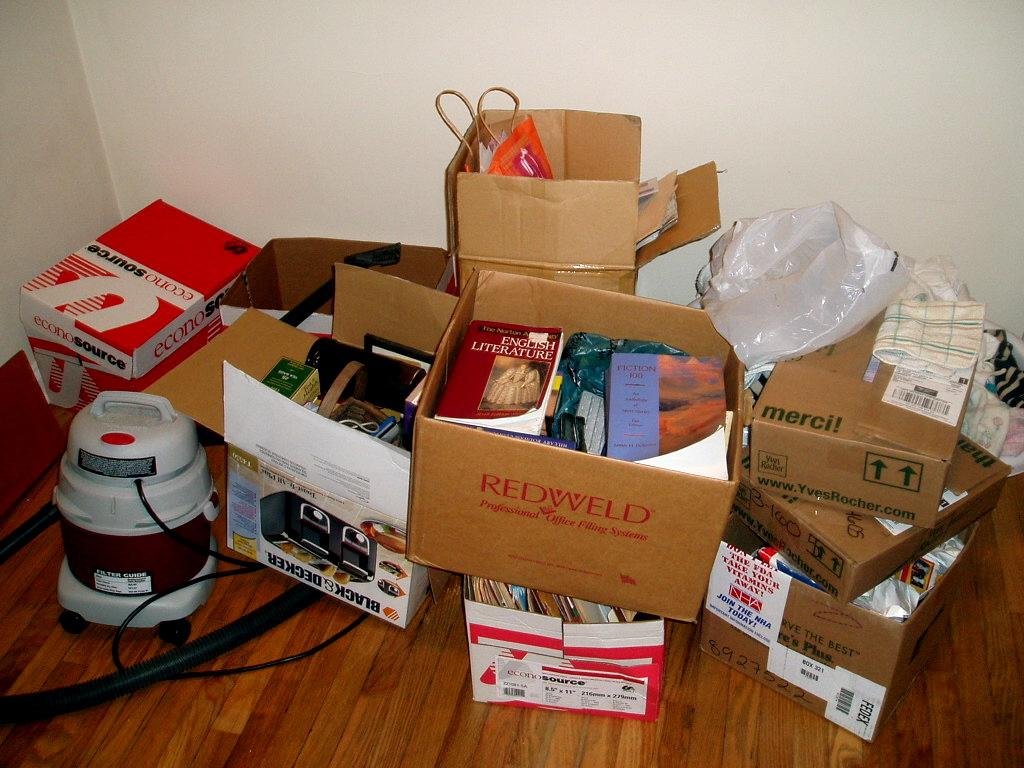<image>
Present a compact description of the photo's key features. A Black and Decker toaster box is in a stack of other boxes. 